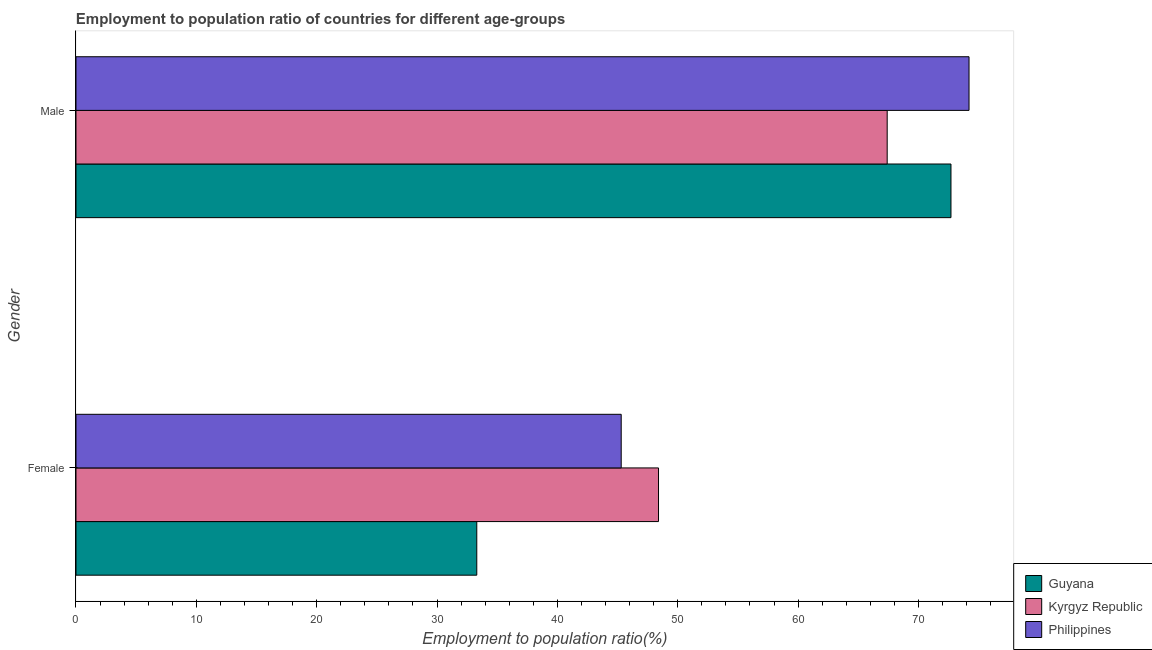How many groups of bars are there?
Your response must be concise. 2. Are the number of bars per tick equal to the number of legend labels?
Provide a short and direct response. Yes. Are the number of bars on each tick of the Y-axis equal?
Give a very brief answer. Yes. How many bars are there on the 2nd tick from the top?
Offer a very short reply. 3. What is the label of the 1st group of bars from the top?
Your response must be concise. Male. What is the employment to population ratio(female) in Philippines?
Keep it short and to the point. 45.3. Across all countries, what is the maximum employment to population ratio(female)?
Ensure brevity in your answer.  48.4. Across all countries, what is the minimum employment to population ratio(female)?
Keep it short and to the point. 33.3. In which country was the employment to population ratio(female) maximum?
Offer a terse response. Kyrgyz Republic. In which country was the employment to population ratio(female) minimum?
Your answer should be very brief. Guyana. What is the total employment to population ratio(female) in the graph?
Provide a short and direct response. 127. What is the difference between the employment to population ratio(male) in Kyrgyz Republic and that in Guyana?
Offer a very short reply. -5.3. What is the difference between the employment to population ratio(female) in Guyana and the employment to population ratio(male) in Philippines?
Provide a succinct answer. -40.9. What is the average employment to population ratio(female) per country?
Ensure brevity in your answer.  42.33. What is the difference between the employment to population ratio(male) and employment to population ratio(female) in Kyrgyz Republic?
Provide a short and direct response. 19. In how many countries, is the employment to population ratio(female) greater than 48 %?
Your response must be concise. 1. What is the ratio of the employment to population ratio(male) in Guyana to that in Kyrgyz Republic?
Offer a very short reply. 1.08. What does the 3rd bar from the top in Male represents?
Offer a very short reply. Guyana. What does the 3rd bar from the bottom in Male represents?
Your answer should be very brief. Philippines. Are all the bars in the graph horizontal?
Your response must be concise. Yes. Are the values on the major ticks of X-axis written in scientific E-notation?
Give a very brief answer. No. Does the graph contain any zero values?
Keep it short and to the point. No. What is the title of the graph?
Give a very brief answer. Employment to population ratio of countries for different age-groups. What is the label or title of the X-axis?
Provide a short and direct response. Employment to population ratio(%). What is the Employment to population ratio(%) in Guyana in Female?
Provide a succinct answer. 33.3. What is the Employment to population ratio(%) in Kyrgyz Republic in Female?
Your answer should be very brief. 48.4. What is the Employment to population ratio(%) in Philippines in Female?
Offer a very short reply. 45.3. What is the Employment to population ratio(%) in Guyana in Male?
Offer a terse response. 72.7. What is the Employment to population ratio(%) in Kyrgyz Republic in Male?
Make the answer very short. 67.4. What is the Employment to population ratio(%) of Philippines in Male?
Your response must be concise. 74.2. Across all Gender, what is the maximum Employment to population ratio(%) of Guyana?
Ensure brevity in your answer.  72.7. Across all Gender, what is the maximum Employment to population ratio(%) of Kyrgyz Republic?
Your answer should be compact. 67.4. Across all Gender, what is the maximum Employment to population ratio(%) in Philippines?
Give a very brief answer. 74.2. Across all Gender, what is the minimum Employment to population ratio(%) of Guyana?
Offer a very short reply. 33.3. Across all Gender, what is the minimum Employment to population ratio(%) in Kyrgyz Republic?
Offer a very short reply. 48.4. Across all Gender, what is the minimum Employment to population ratio(%) of Philippines?
Ensure brevity in your answer.  45.3. What is the total Employment to population ratio(%) of Guyana in the graph?
Ensure brevity in your answer.  106. What is the total Employment to population ratio(%) of Kyrgyz Republic in the graph?
Offer a terse response. 115.8. What is the total Employment to population ratio(%) of Philippines in the graph?
Make the answer very short. 119.5. What is the difference between the Employment to population ratio(%) in Guyana in Female and that in Male?
Ensure brevity in your answer.  -39.4. What is the difference between the Employment to population ratio(%) of Kyrgyz Republic in Female and that in Male?
Provide a short and direct response. -19. What is the difference between the Employment to population ratio(%) in Philippines in Female and that in Male?
Give a very brief answer. -28.9. What is the difference between the Employment to population ratio(%) in Guyana in Female and the Employment to population ratio(%) in Kyrgyz Republic in Male?
Your answer should be compact. -34.1. What is the difference between the Employment to population ratio(%) of Guyana in Female and the Employment to population ratio(%) of Philippines in Male?
Keep it short and to the point. -40.9. What is the difference between the Employment to population ratio(%) in Kyrgyz Republic in Female and the Employment to population ratio(%) in Philippines in Male?
Your answer should be compact. -25.8. What is the average Employment to population ratio(%) of Guyana per Gender?
Make the answer very short. 53. What is the average Employment to population ratio(%) of Kyrgyz Republic per Gender?
Your answer should be very brief. 57.9. What is the average Employment to population ratio(%) in Philippines per Gender?
Your answer should be compact. 59.75. What is the difference between the Employment to population ratio(%) in Guyana and Employment to population ratio(%) in Kyrgyz Republic in Female?
Offer a very short reply. -15.1. What is the difference between the Employment to population ratio(%) in Kyrgyz Republic and Employment to population ratio(%) in Philippines in Female?
Make the answer very short. 3.1. What is the ratio of the Employment to population ratio(%) of Guyana in Female to that in Male?
Provide a succinct answer. 0.46. What is the ratio of the Employment to population ratio(%) in Kyrgyz Republic in Female to that in Male?
Ensure brevity in your answer.  0.72. What is the ratio of the Employment to population ratio(%) of Philippines in Female to that in Male?
Provide a short and direct response. 0.61. What is the difference between the highest and the second highest Employment to population ratio(%) of Guyana?
Your response must be concise. 39.4. What is the difference between the highest and the second highest Employment to population ratio(%) in Kyrgyz Republic?
Provide a short and direct response. 19. What is the difference between the highest and the second highest Employment to population ratio(%) in Philippines?
Make the answer very short. 28.9. What is the difference between the highest and the lowest Employment to population ratio(%) of Guyana?
Give a very brief answer. 39.4. What is the difference between the highest and the lowest Employment to population ratio(%) of Kyrgyz Republic?
Provide a short and direct response. 19. What is the difference between the highest and the lowest Employment to population ratio(%) in Philippines?
Your answer should be compact. 28.9. 